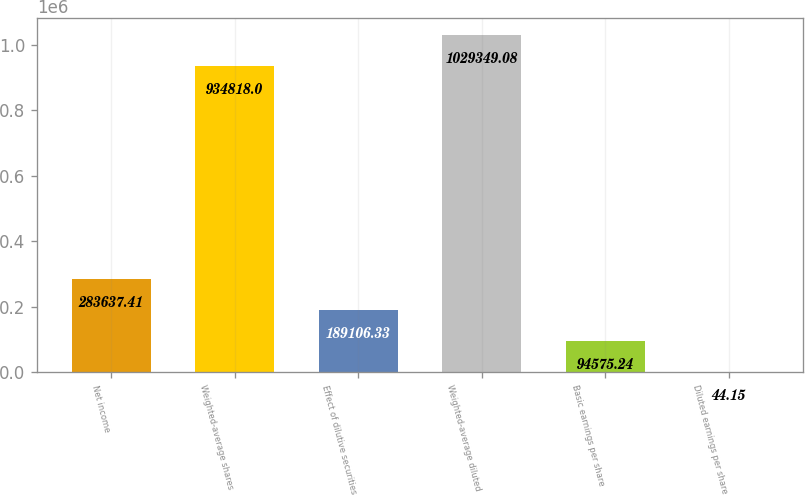Convert chart to OTSL. <chart><loc_0><loc_0><loc_500><loc_500><bar_chart><fcel>Net income<fcel>Weighted-average shares<fcel>Effect of dilutive securities<fcel>Weighted-average diluted<fcel>Basic earnings per share<fcel>Diluted earnings per share<nl><fcel>283637<fcel>934818<fcel>189106<fcel>1.02935e+06<fcel>94575.2<fcel>44.15<nl></chart> 